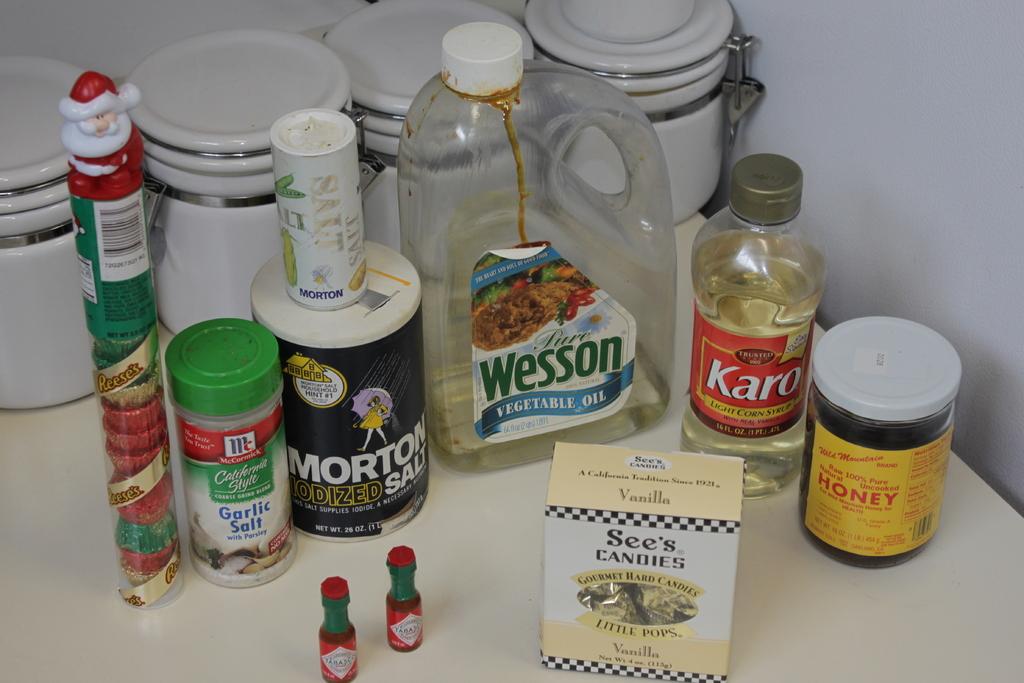What is in the jar on the far right with the yellow label?
Provide a short and direct response. Honey. What brand is the table salt?
Your response must be concise. Morton. 